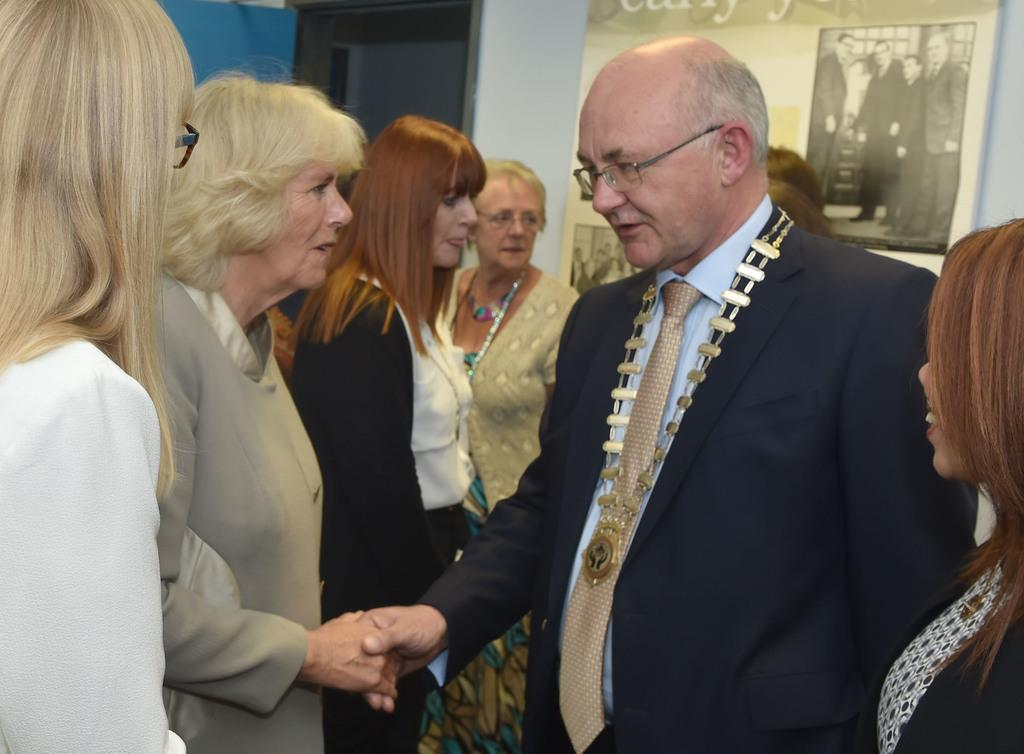How many people are in the image? There are people in the image. What are the two persons doing in the image? Two persons are shaking hands in the image. What can be seen on the wall in the image? There is a frame on the wall in the image. What number is written on the frame in the image? There is no number written on the frame in the image. What type of adjustment is being made to the frame in the image? There is no adjustment being made to the frame in the image; it is simply hanging on the wall. 